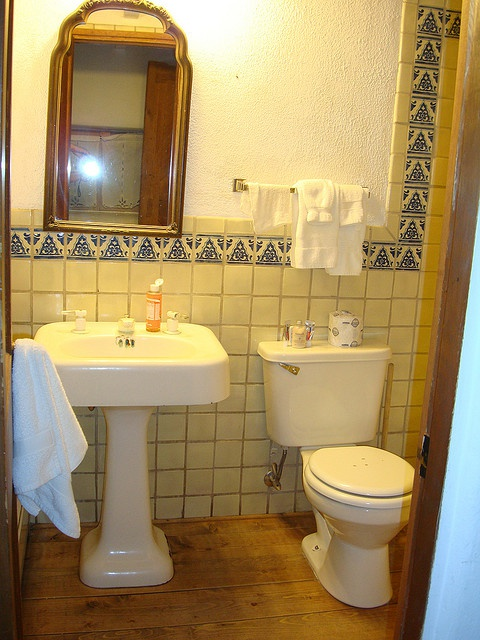Describe the objects in this image and their specific colors. I can see toilet in black, tan, khaki, and gray tones, sink in black, khaki, and tan tones, bottle in black, khaki, orange, and gold tones, and people in black, white, darkgray, and lightblue tones in this image. 